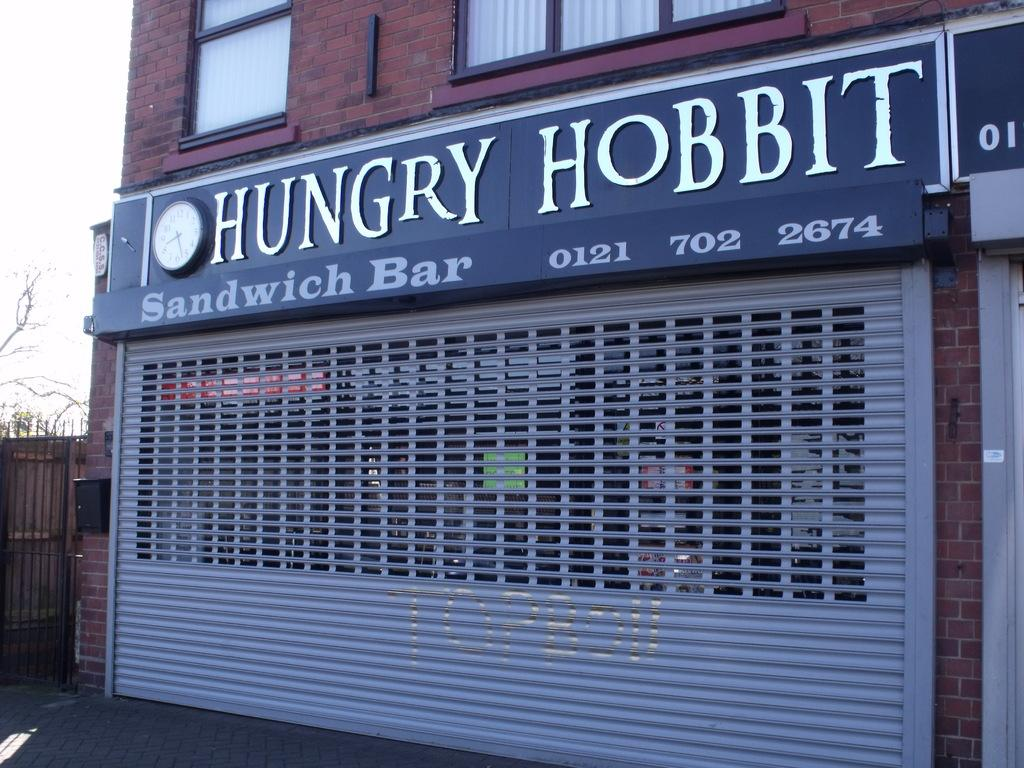What type of structure is present in the image? There is a building in the image. What is attached to the building? The building has a board and a clock on it. What can be seen in the background of the image? The sky is visible in the background of the image. What type of action is taking place in the hole in the building? There is no hole present in the building in the image, so no action can be observed in a hole. 